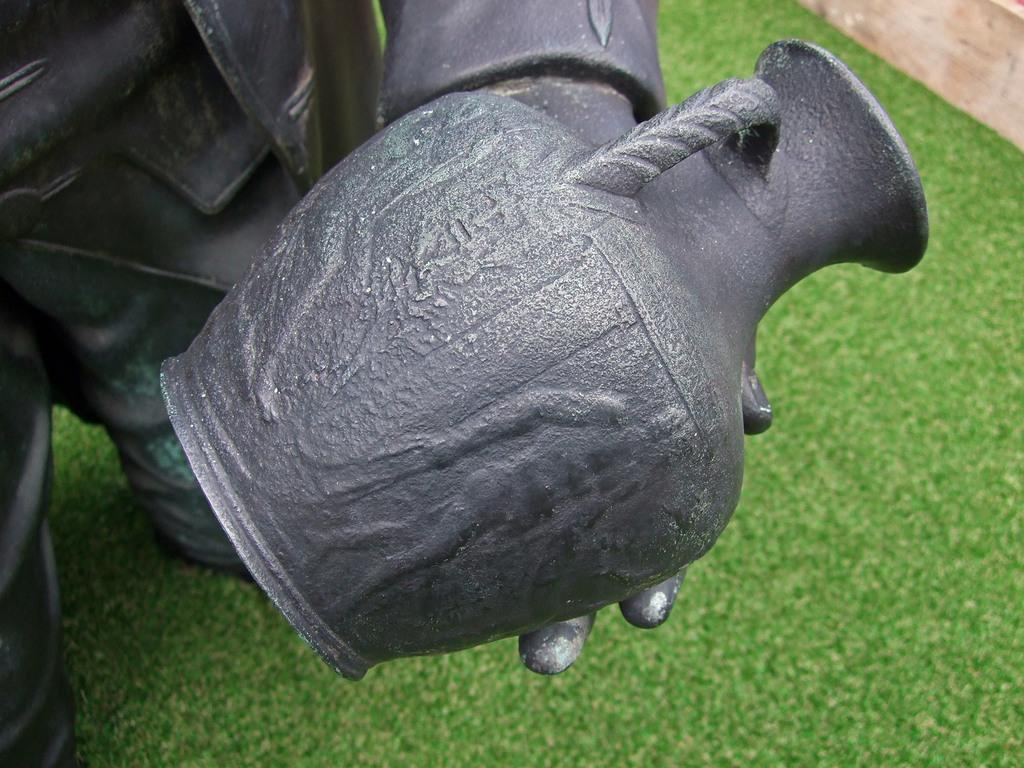What is the main subject in the center of the image? There is a sculpture in the center of the image. What is the color of the sculpture? The sculpture is black in color. What can be seen in the background of the image? There is a wood and grass in the background of the image. What type of soup is being served in the image? There is no soup present in the image; it features a black sculpture and a background with wood and grass. 